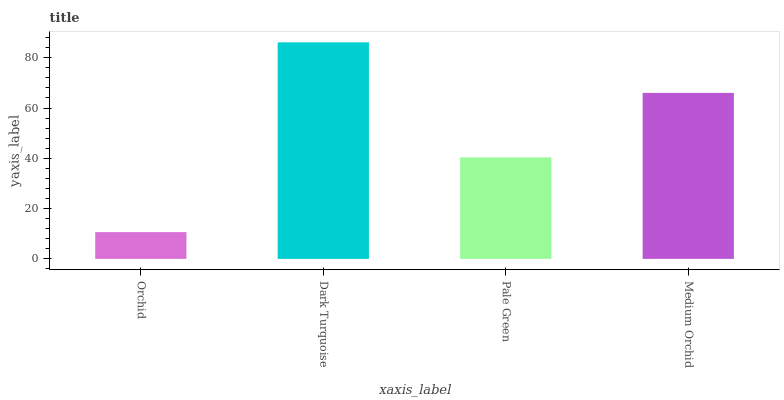Is Orchid the minimum?
Answer yes or no. Yes. Is Dark Turquoise the maximum?
Answer yes or no. Yes. Is Pale Green the minimum?
Answer yes or no. No. Is Pale Green the maximum?
Answer yes or no. No. Is Dark Turquoise greater than Pale Green?
Answer yes or no. Yes. Is Pale Green less than Dark Turquoise?
Answer yes or no. Yes. Is Pale Green greater than Dark Turquoise?
Answer yes or no. No. Is Dark Turquoise less than Pale Green?
Answer yes or no. No. Is Medium Orchid the high median?
Answer yes or no. Yes. Is Pale Green the low median?
Answer yes or no. Yes. Is Dark Turquoise the high median?
Answer yes or no. No. Is Orchid the low median?
Answer yes or no. No. 